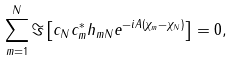Convert formula to latex. <formula><loc_0><loc_0><loc_500><loc_500>\sum _ { m = 1 } ^ { N } \Im \left [ c _ { N } c _ { m } ^ { * } h _ { m N } e ^ { - i A ( \chi _ { m } - \chi _ { N } ) } \right ] = 0 ,</formula> 